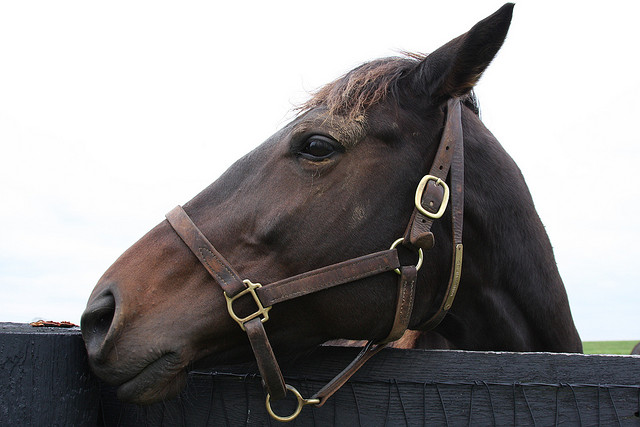<image>Is this horse a metal winner? It is not certain whether this horse is a medal winner. Is this horse a metal winner? I am not sure if this horse is a medal winner. But it can be seen not to be a medal winner. 